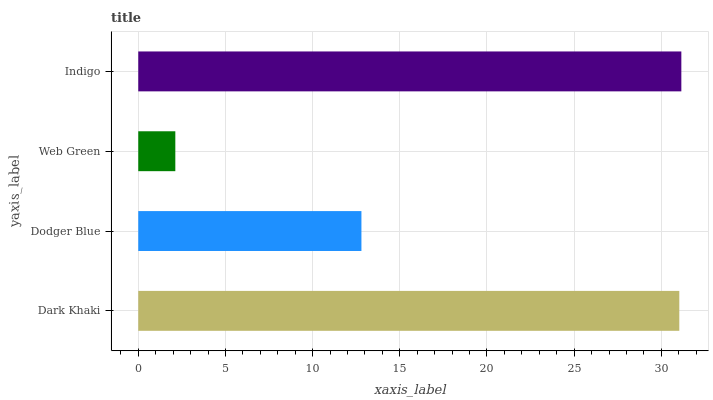Is Web Green the minimum?
Answer yes or no. Yes. Is Indigo the maximum?
Answer yes or no. Yes. Is Dodger Blue the minimum?
Answer yes or no. No. Is Dodger Blue the maximum?
Answer yes or no. No. Is Dark Khaki greater than Dodger Blue?
Answer yes or no. Yes. Is Dodger Blue less than Dark Khaki?
Answer yes or no. Yes. Is Dodger Blue greater than Dark Khaki?
Answer yes or no. No. Is Dark Khaki less than Dodger Blue?
Answer yes or no. No. Is Dark Khaki the high median?
Answer yes or no. Yes. Is Dodger Blue the low median?
Answer yes or no. Yes. Is Dodger Blue the high median?
Answer yes or no. No. Is Web Green the low median?
Answer yes or no. No. 